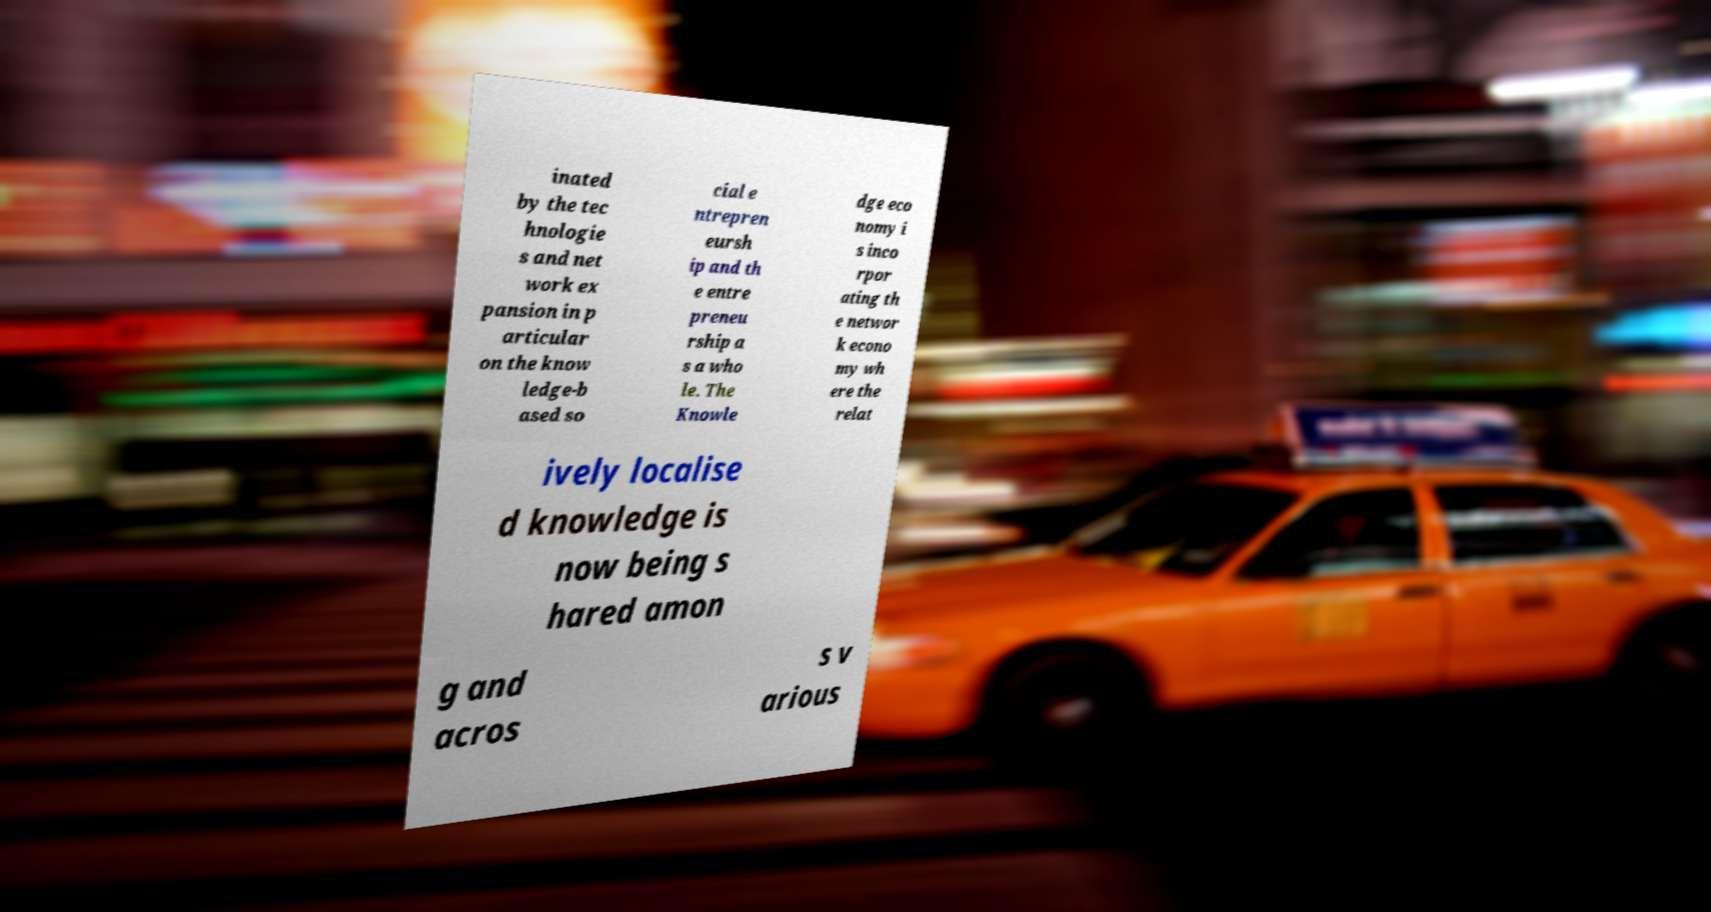What messages or text are displayed in this image? I need them in a readable, typed format. inated by the tec hnologie s and net work ex pansion in p articular on the know ledge-b ased so cial e ntrepren eursh ip and th e entre preneu rship a s a who le. The Knowle dge eco nomy i s inco rpor ating th e networ k econo my wh ere the relat ively localise d knowledge is now being s hared amon g and acros s v arious 